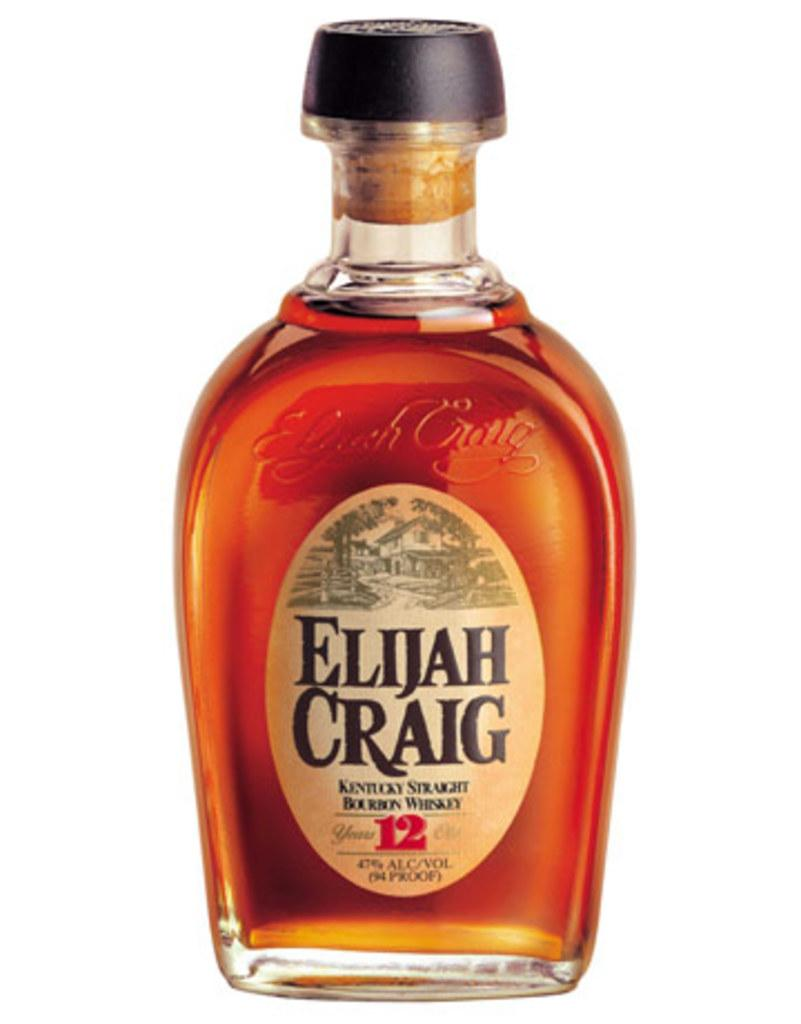Provide a one-sentence caption for the provided image. A simple image of a bottle of Elijah Craig whisky against a white background. 